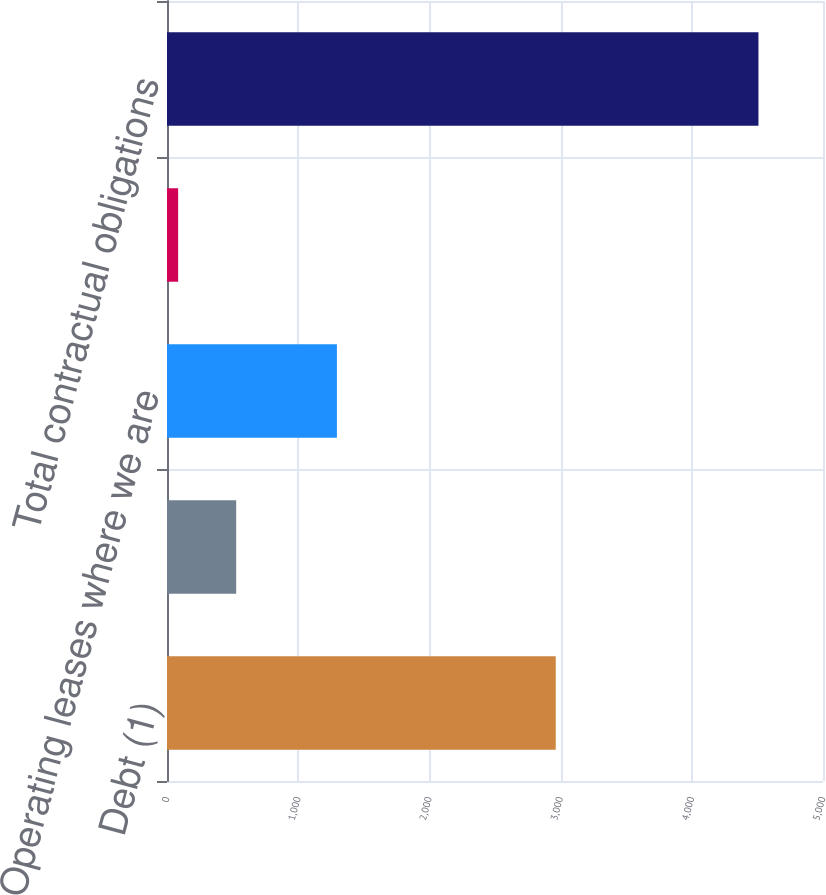<chart> <loc_0><loc_0><loc_500><loc_500><bar_chart><fcel>Debt (1)<fcel>Capital lease obligations (1)<fcel>Operating leases where we are<fcel>Other noncurrent liabilities<fcel>Total contractual obligations<nl><fcel>2963<fcel>527.3<fcel>1295<fcel>85<fcel>4508<nl></chart> 